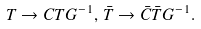Convert formula to latex. <formula><loc_0><loc_0><loc_500><loc_500>T \rightarrow C T G ^ { - 1 } , \, \bar { T } \rightarrow \bar { C } \bar { T } G ^ { - 1 } .</formula> 